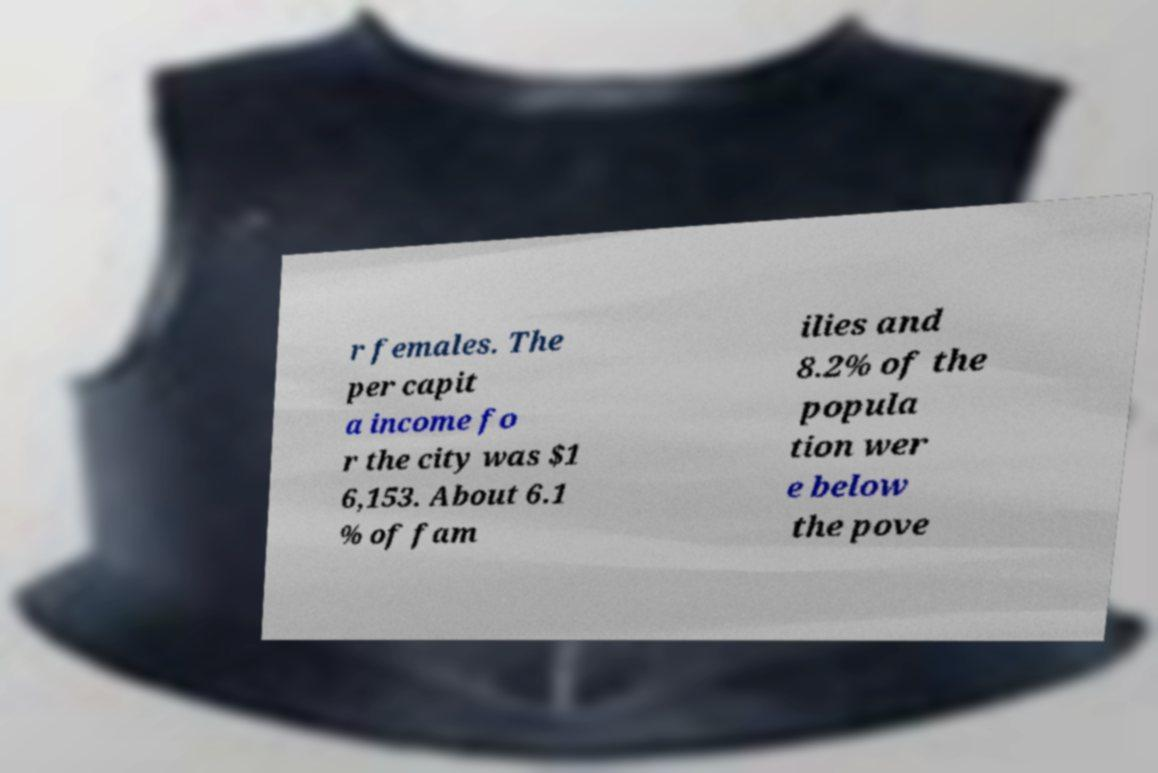Please identify and transcribe the text found in this image. r females. The per capit a income fo r the city was $1 6,153. About 6.1 % of fam ilies and 8.2% of the popula tion wer e below the pove 